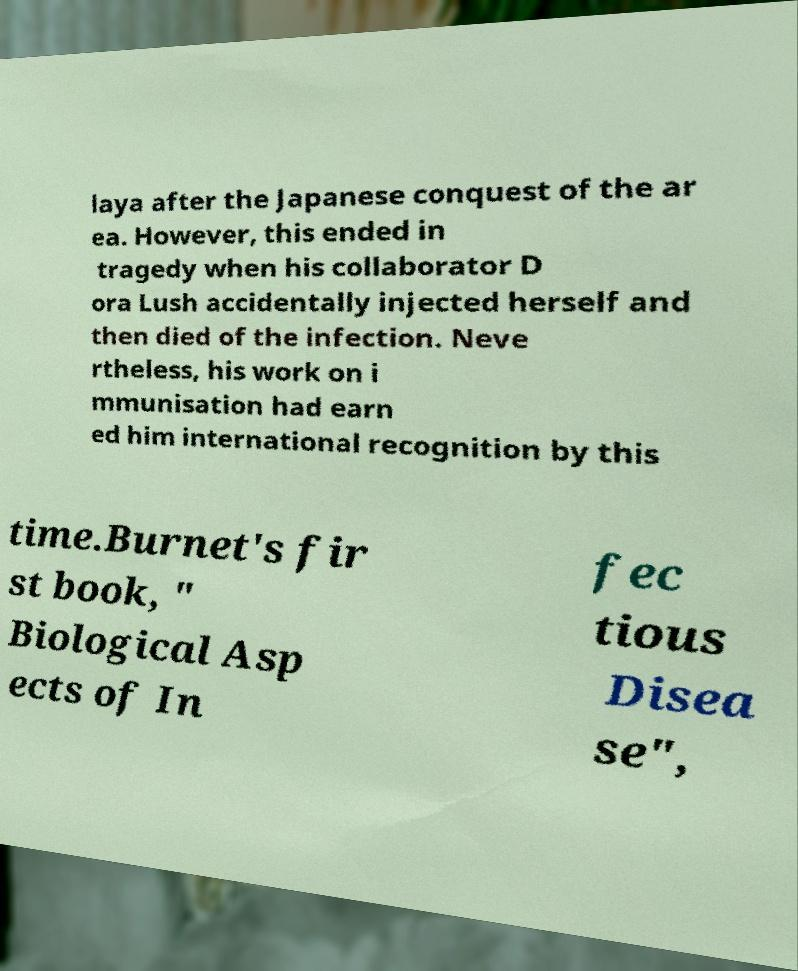Can you accurately transcribe the text from the provided image for me? laya after the Japanese conquest of the ar ea. However, this ended in tragedy when his collaborator D ora Lush accidentally injected herself and then died of the infection. Neve rtheless, his work on i mmunisation had earn ed him international recognition by this time.Burnet's fir st book, " Biological Asp ects of In fec tious Disea se", 